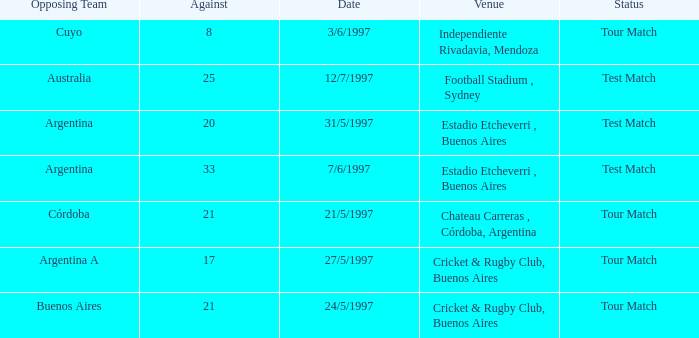Which venue has an against value larger than 21 and had Argentina as an opposing team. Estadio Etcheverri , Buenos Aires. 